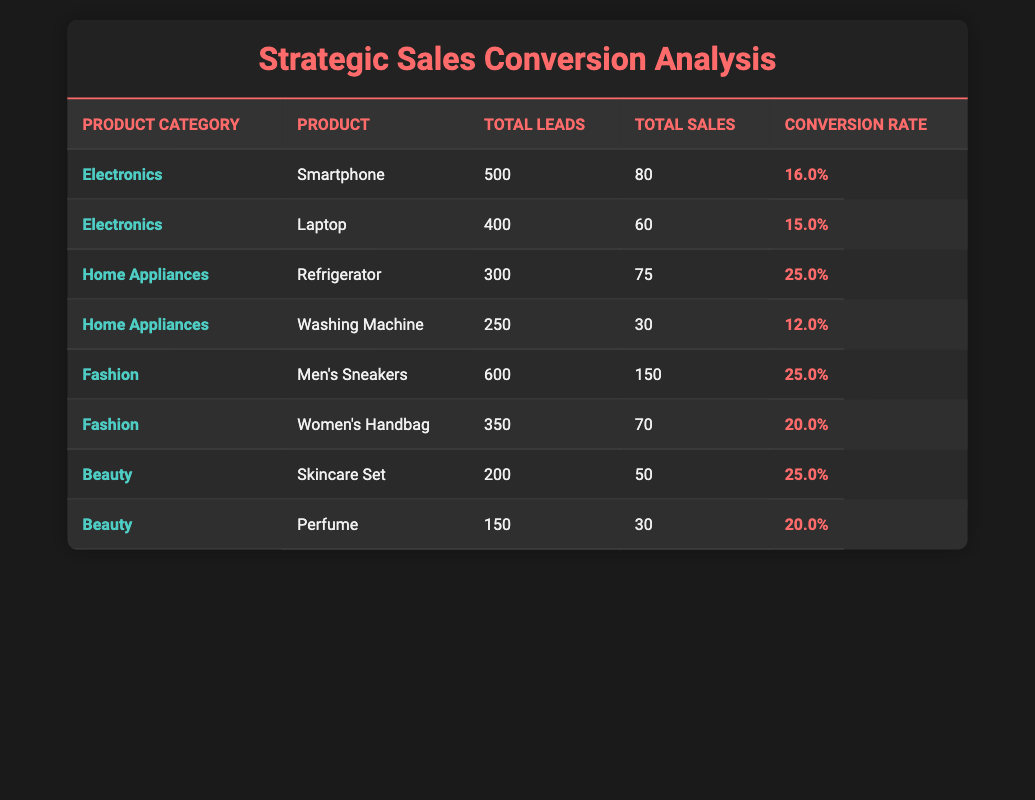What is the conversion rate for the Men's Sneakers? From the table, we can directly locate the row for Men's Sneakers under the Fashion category, which shows a conversion rate of 25.0%.
Answer: 25.0% Which product category has the highest conversion rate? The highest conversion rate can be found by looking at the conversion rates in each product category. Home Appliances with the Refrigerator shows a conversion rate of 25.0%, which is the highest among all listed categories.
Answer: Home Appliances What is the total number of leads for Electronics? To find the total leads for Electronics, we add the Total Leads for both products under Electronics: 500 (Smartphone) + 400 (Laptop) = 900.
Answer: 900 Is the conversion rate for the Refrigerator greater than 20%? The table shows that the Refrigerator has a conversion rate of 25.0%, which is greater than 20%. Therefore, the statement is true.
Answer: Yes What is the average conversion rate for the Beauty category? To find the average conversion rate for the Beauty category, we take the conversion rates for both products: Skincare Set (25.0%) and Perfume (20.0%). We add them: 25.0 + 20.0 = 45.0. There are 2 products, so the average is 45.0 / 2 = 22.5%.
Answer: 22.5% Which product has the lowest conversion rate? By checking each conversion rate in the table, the Washing Machine has a conversion rate of 12.0%, which is lower than all other products listed.
Answer: Washing Machine How many total sales were made for all fashion products? Adding the total sales for both fashion products: Men's Sneakers (150) + Women's Handbag (70) gives 150 + 70 = 220 total sales.
Answer: 220 Does the Laptop have better sales performance than the Washing Machine? The total sales for the Laptop is 60, while for the Washing Machine, it's 30. Since 60 is greater than 30, the Laptop has better sales performance.
Answer: Yes What is the difference in conversion rates between Electronics and Home Appliances? We take the average conversion rate for Electronics (average of 16.0% for Smartphone and 15.0% for Laptop = 15.5%) and the conversion rate for Home Appliances (25.0% for Refrigerator and 12.0% for Washing Machine = 18.5%). The difference is 18.5% - 15.5% = 3.0%.
Answer: 3.0% 